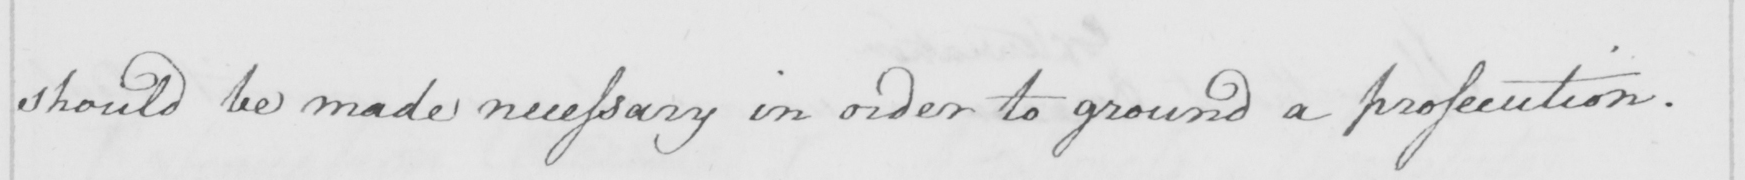What does this handwritten line say? should be made necessary in order to ground a prosecution . 